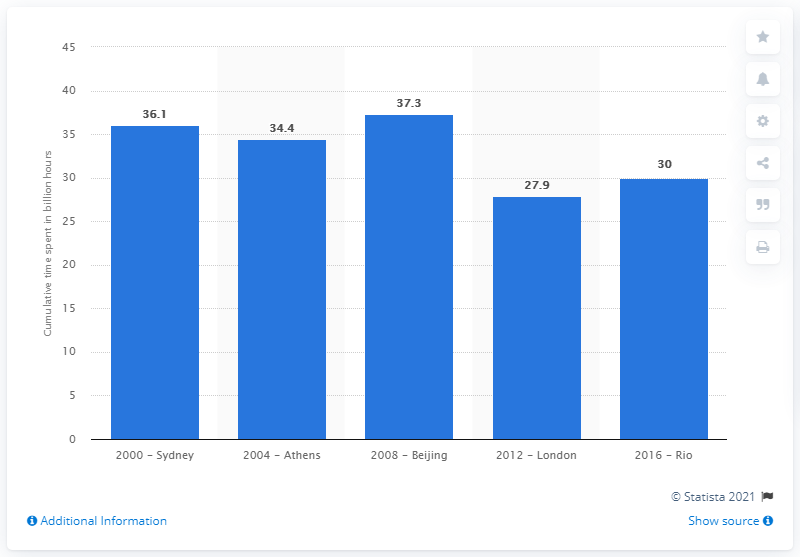Outline some significant characteristics in this image. In 2016, viewers spent an average of 30 hours watching the Olympic Games held in Rio de Janeiro. 